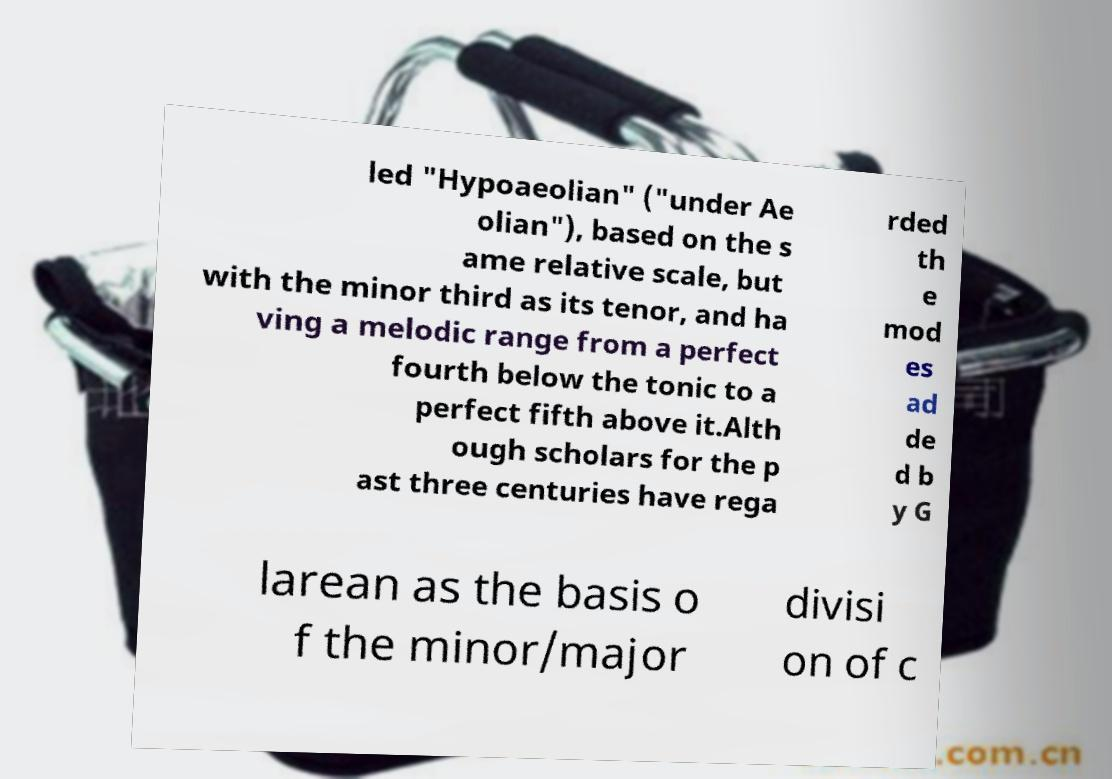I need the written content from this picture converted into text. Can you do that? led "Hypoaeolian" ("under Ae olian"), based on the s ame relative scale, but with the minor third as its tenor, and ha ving a melodic range from a perfect fourth below the tonic to a perfect fifth above it.Alth ough scholars for the p ast three centuries have rega rded th e mod es ad de d b y G larean as the basis o f the minor/major divisi on of c 